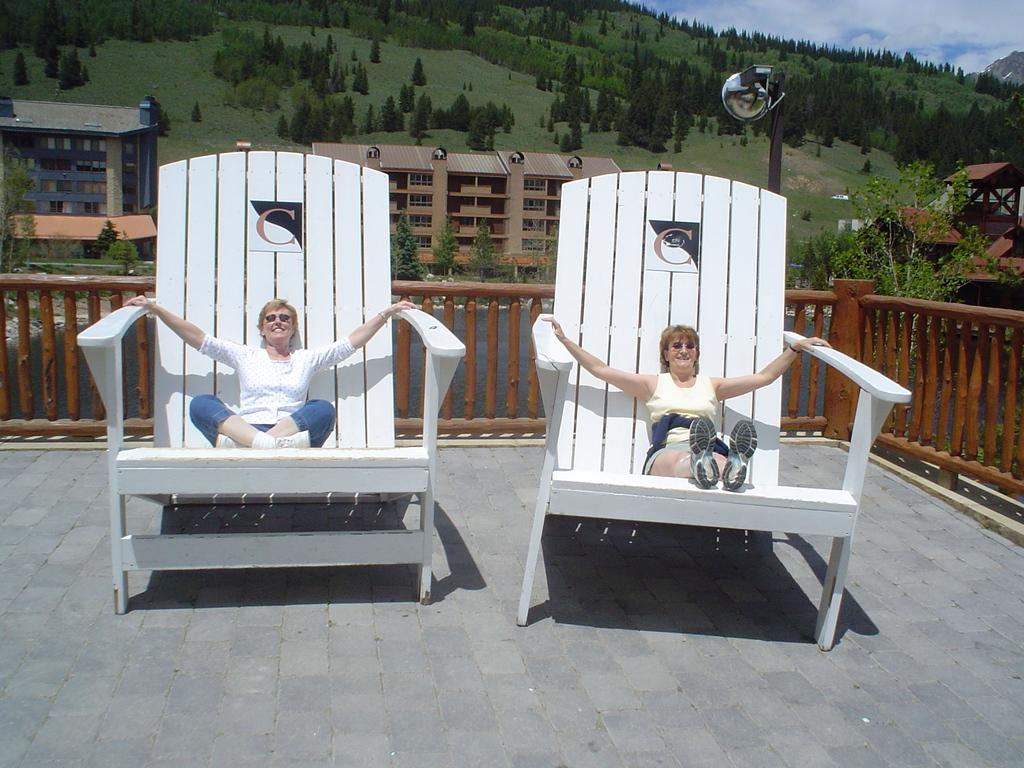How many women are in the image? There are two women in the image. What are the women doing in the image? The women are sitting on a chair. Can you describe the chair in the image? The chair appears to be large. What can be seen in the background of the image? There is a fence, buildings, trees, plants, grass, a pole, and a cloudy sky in the background of the image. What type of toys can be seen in the hands of the women in the image? There are no toys present in the image; the women are not holding any objects. Are the women driving a vehicle in the image? There is no vehicle present in the image, and the women are sitting on a chair, not driving. 